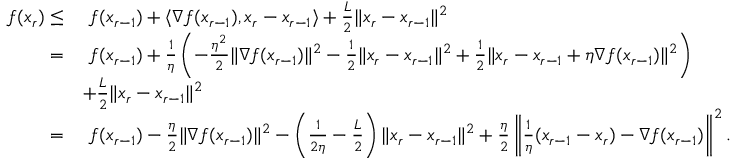Convert formula to latex. <formula><loc_0><loc_0><loc_500><loc_500>\begin{array} { r l } { f ( x _ { r } ) \leq } & { \ f ( x _ { r - 1 } ) + \langle \nabla f ( x _ { r - 1 } ) , x _ { r } - x _ { r - 1 } \rangle + \frac { L } { 2 } \| x _ { r } - x _ { r - 1 } \| ^ { 2 } } \\ { = } & { \ f ( x _ { r - 1 } ) + \frac { 1 } { \eta } \left ( - \frac { \eta ^ { 2 } } { 2 } \| \nabla f ( x _ { r - 1 } ) \| ^ { 2 } - \frac { 1 } { 2 } \| x _ { r } - x _ { r - 1 } \| ^ { 2 } + \frac { 1 } { 2 } \| x _ { r } - x _ { r - 1 } + \eta \nabla f ( x _ { r - 1 } ) \| ^ { 2 } \right ) } \\ & { + \frac { L } { 2 } \| x _ { r } - x _ { r - 1 } \| ^ { 2 } } \\ { = } & { \ f ( x _ { r - 1 } ) - \frac { \eta } { 2 } \| \nabla f ( x _ { r - 1 } ) \| ^ { 2 } - \left ( \frac { 1 } { 2 \eta } - \frac { L } { 2 } \right ) \| x _ { r } - x _ { r - 1 } \| ^ { 2 } + \frac { \eta } { 2 } \left \| \frac { 1 } { \eta } ( x _ { r - 1 } - x _ { r } ) - \nabla f ( x _ { r - 1 } ) \right \| ^ { 2 } . } \end{array}</formula> 